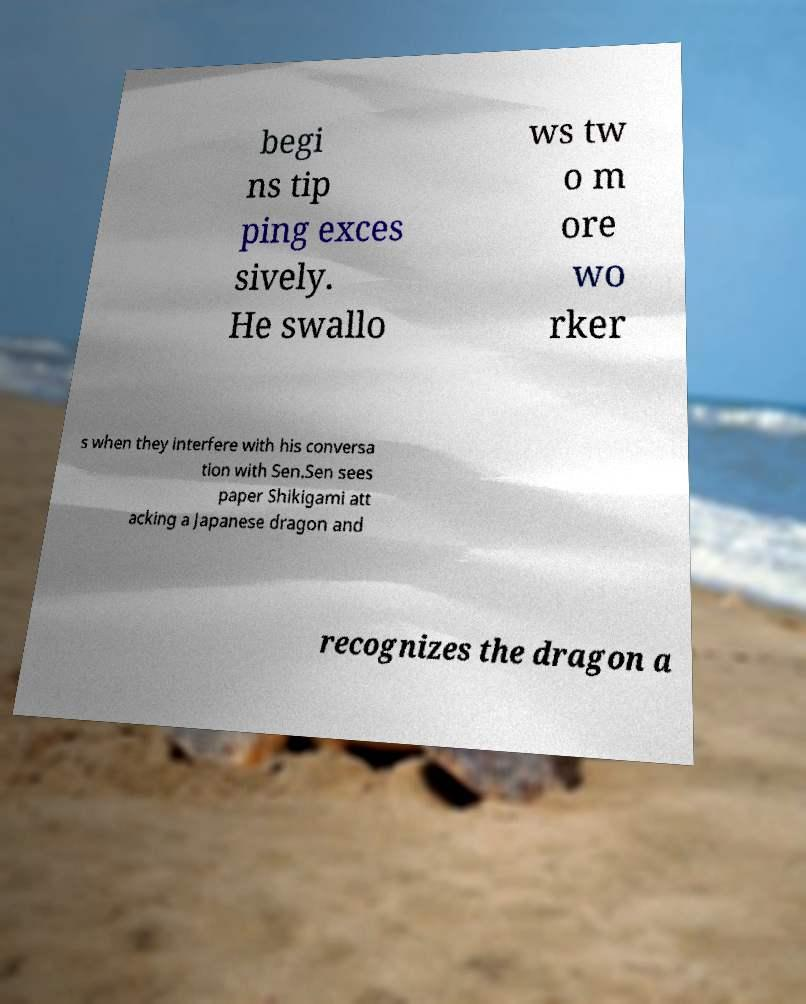For documentation purposes, I need the text within this image transcribed. Could you provide that? begi ns tip ping exces sively. He swallo ws tw o m ore wo rker s when they interfere with his conversa tion with Sen.Sen sees paper Shikigami att acking a Japanese dragon and recognizes the dragon a 